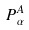<formula> <loc_0><loc_0><loc_500><loc_500>P _ { \alpha } ^ { A }</formula> 